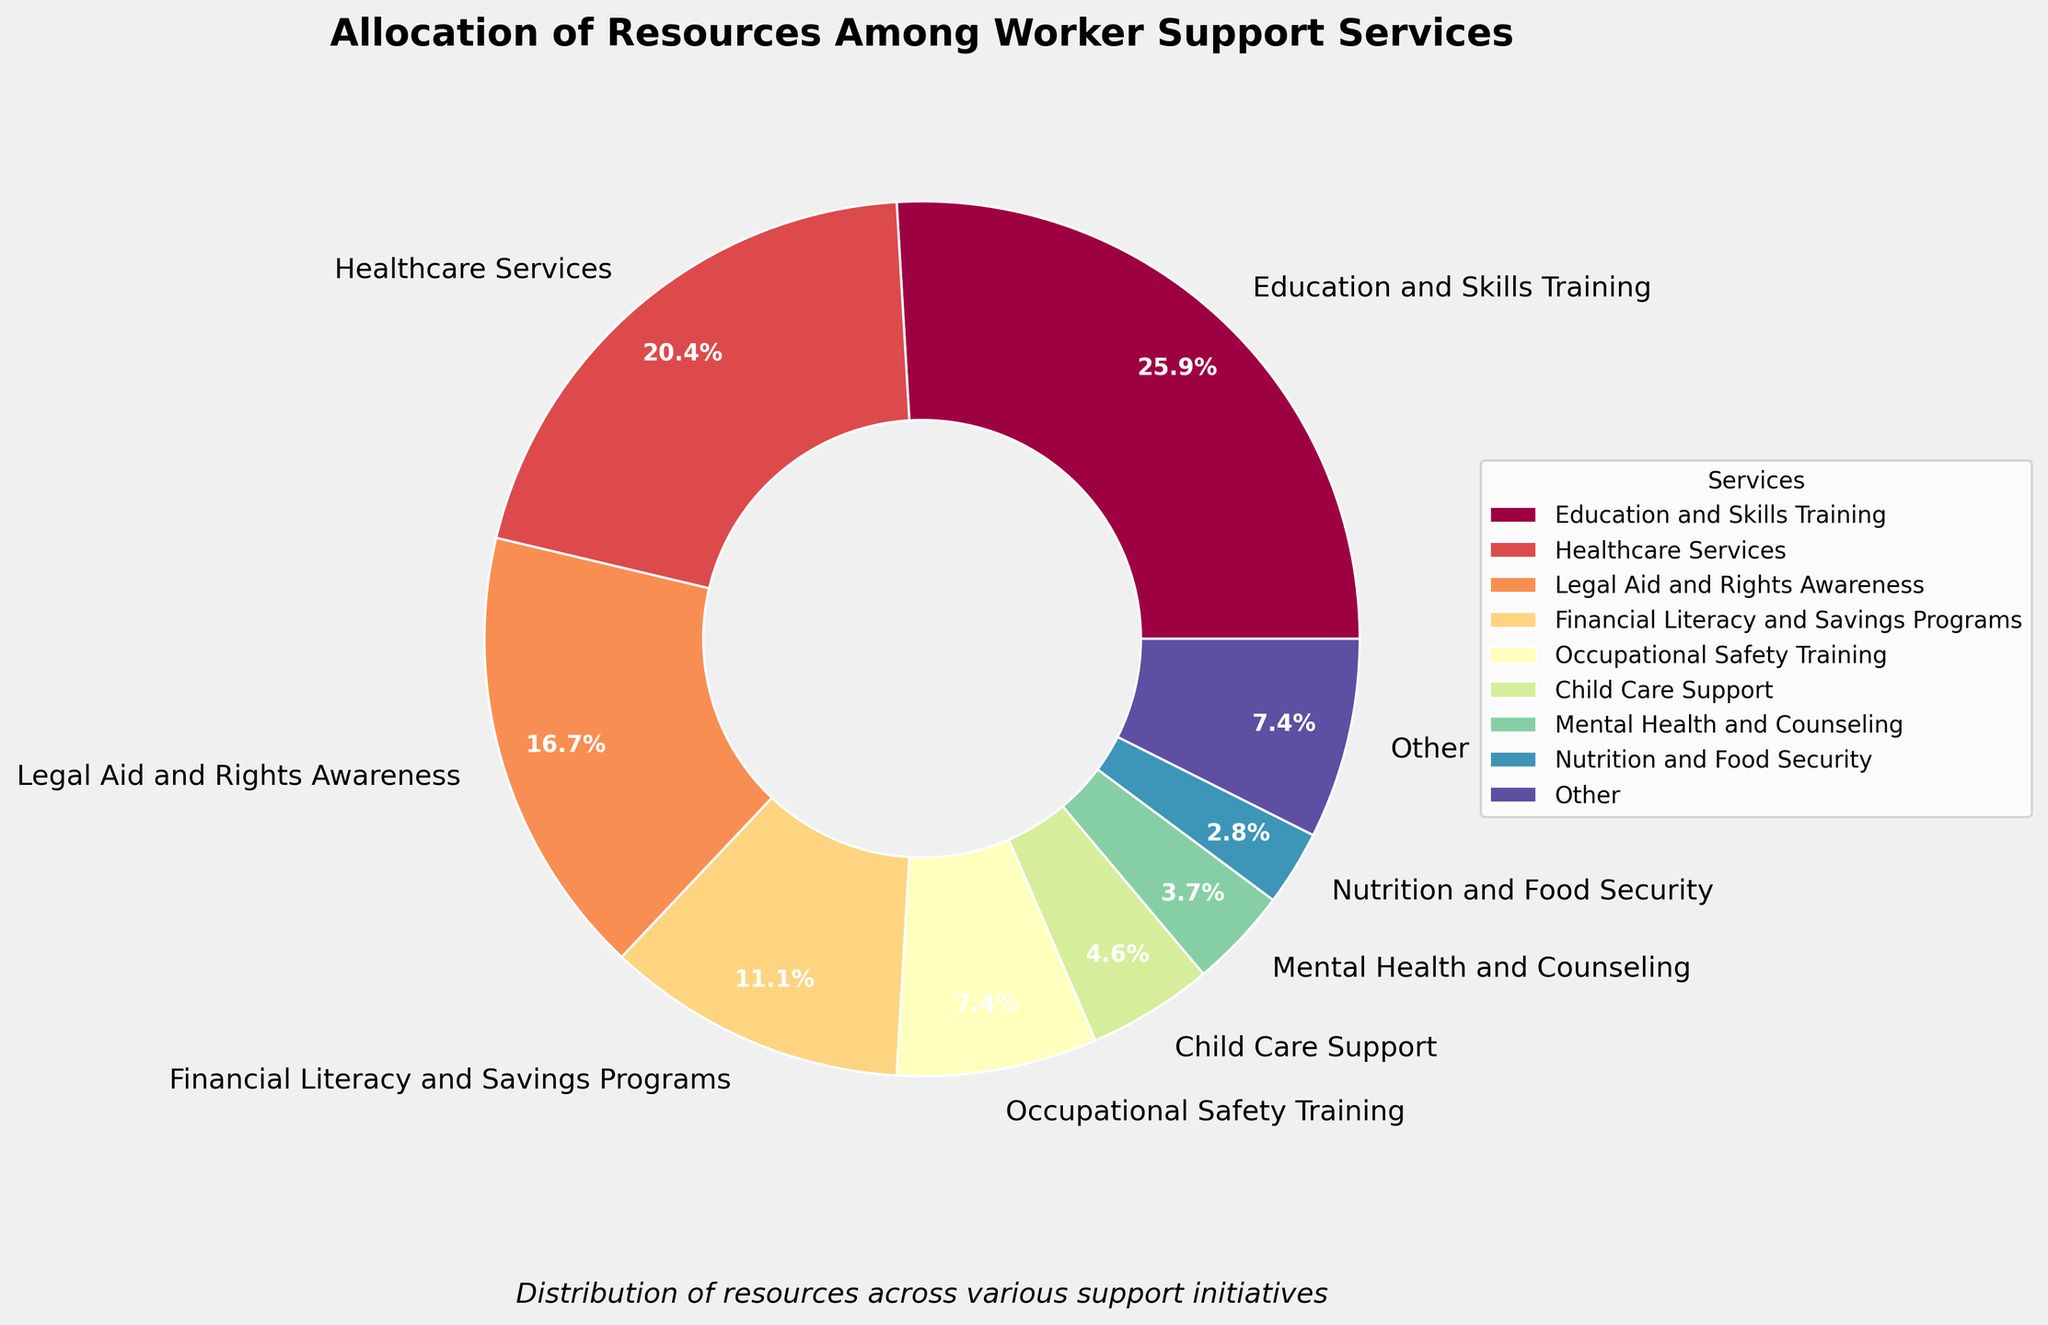Which service receives the highest allocation of resources? The pie chart shows the different percentages of resource allocation with labels. The slice labeled 'Education and Skills Training' is the largest.
Answer: Education and Skills Training What percentage of resources is allocated to Healthcare Services? The pie chart has a labeled slice for 'Healthcare Services', which shows the percentage directly on the slice.
Answer: 22% Which three services receive the least allocation of resources? The pie chart combines several services under 'Other'. The slices that are merged into 'Other' can be identified from the list: Transportation Assistance, Housing Support, Language Classes, Digital Literacy Programs, and Women's Empowerment Initiatives.
Answer: Digital Literacy Programs, Women's Empowerment Initiatives, Language Classes How many percent more resources are allocated to Education and Skills Training than to Legal Aid and Rights Awareness? Subtract the percentage allocated to Legal Aid and Rights Awareness from the percentage allocated to Education and Skills Training: 28% - 18% = 10%
Answer: 10% What is the combined percentage of Occupational Safety Training and Financial Literacy and Savings Programs? Add the percentages of Occupational Safety Training and Financial Literacy and Savings Programs: 8% + 12% = 20%
Answer: 20% Is the percentage of resources allocated to Education and Skills Training more than twice the percentage allocated to Occupational Safety Training? Check if the percentage for Education and Skills Training is more than double that of Occupational Safety Training: 28% > 2 * 8%
Answer: Yes Are there more resources allocated to 'Healthcare Services' than 'Legal Aid and Rights Awareness' and 'Child Care Support' combined? Add the percentages of Legal Aid and Rights Awareness and Child Care Support, then compare it to Healthcare Services: 18% + 5% = 23%, which is greater than 22%.
Answer: No By how much percent does Education and Skills Training lead over Mental Health and Counseling? Subtract the percent for Mental Health and Counseling from the percent for Education and Skills Training: 28% - 4% = 24%
Answer: 24% What percentage of resources is allocated to services that are included in the "Other" category? The pie chart combines several smaller allocations into "Other". Summing the listed small percentages under 'Other': 2% + 2% + 2% + 1% + 1% = 8%.
Answer: 8% What are the total percentages allocated to services related to training and education (including Education and Skills Training and Occupational Safety Training)? Add the percentages for Education and Skills Training and Occupational Safety Training: 28% + 8% = 36%
Answer: 36% 